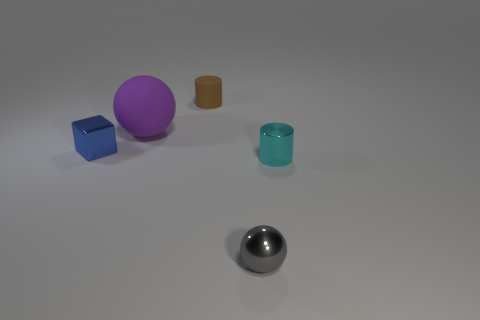Add 4 tiny rubber cylinders. How many objects exist? 9 Subtract all cubes. How many objects are left? 4 Add 4 green metal cubes. How many green metal cubes exist? 4 Subtract 0 green blocks. How many objects are left? 5 Subtract all big brown matte things. Subtract all big purple objects. How many objects are left? 4 Add 2 purple rubber balls. How many purple rubber balls are left? 3 